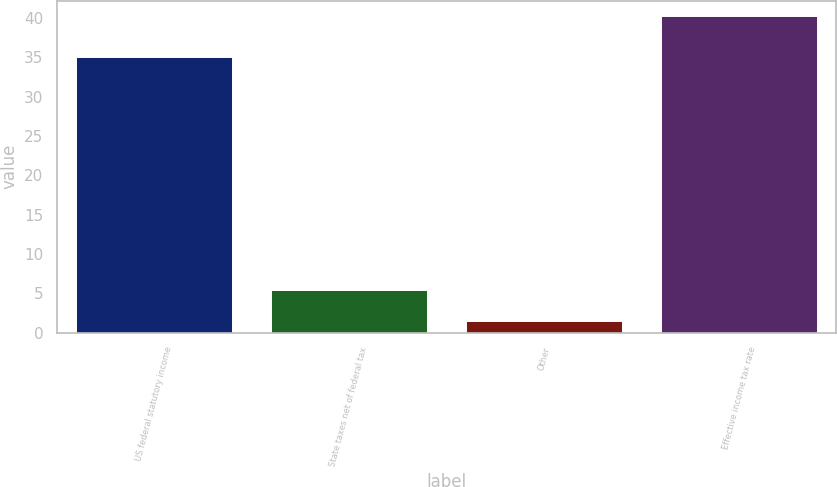Convert chart. <chart><loc_0><loc_0><loc_500><loc_500><bar_chart><fcel>US federal statutory income<fcel>State taxes net of federal tax<fcel>Other<fcel>Effective income tax rate<nl><fcel>35<fcel>5.37<fcel>1.5<fcel>40.2<nl></chart> 